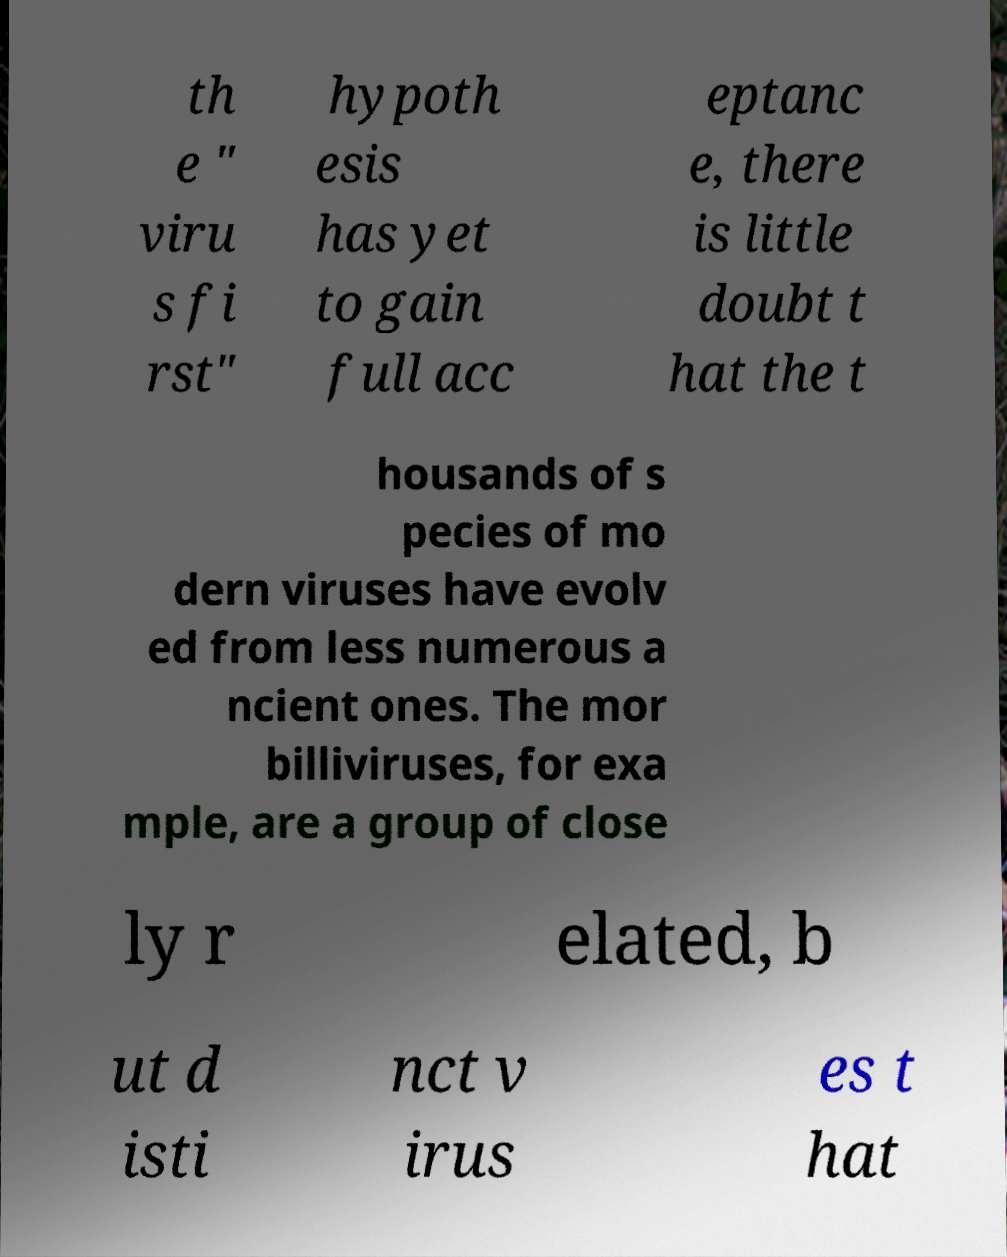Can you read and provide the text displayed in the image?This photo seems to have some interesting text. Can you extract and type it out for me? th e " viru s fi rst" hypoth esis has yet to gain full acc eptanc e, there is little doubt t hat the t housands of s pecies of mo dern viruses have evolv ed from less numerous a ncient ones. The mor billiviruses, for exa mple, are a group of close ly r elated, b ut d isti nct v irus es t hat 